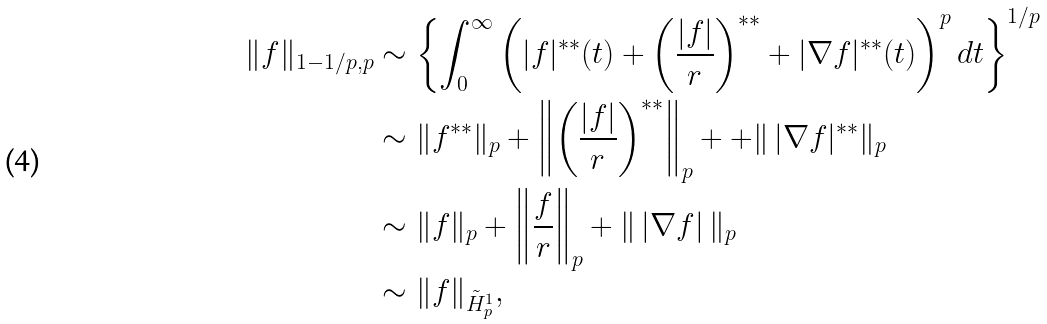<formula> <loc_0><loc_0><loc_500><loc_500>\| f \| _ { 1 - 1 / p , p } & \sim \left \{ \int _ { 0 } ^ { \infty } \left ( | f | ^ { * * } ( t ) + \left ( \frac { | f | } { r } \right ) ^ { * * } + | \nabla f | ^ { * * } ( t ) \right ) ^ { p } d t \right \} ^ { 1 / p } \\ & \sim \| f ^ { * * } \| _ { p } + \left \| \left ( \frac { | f | } { r } \right ) ^ { * * } \right \| _ { p } + + \| \, | \nabla f | ^ { * * } \| _ { p } \\ & \sim \| f \| _ { p } + \left \| \frac { f } { r } \right \| _ { p } + \| \, | \nabla f | \, \| _ { p } \\ & \sim \| f \| _ { \tilde { H } _ { p } ^ { 1 } } ,</formula> 